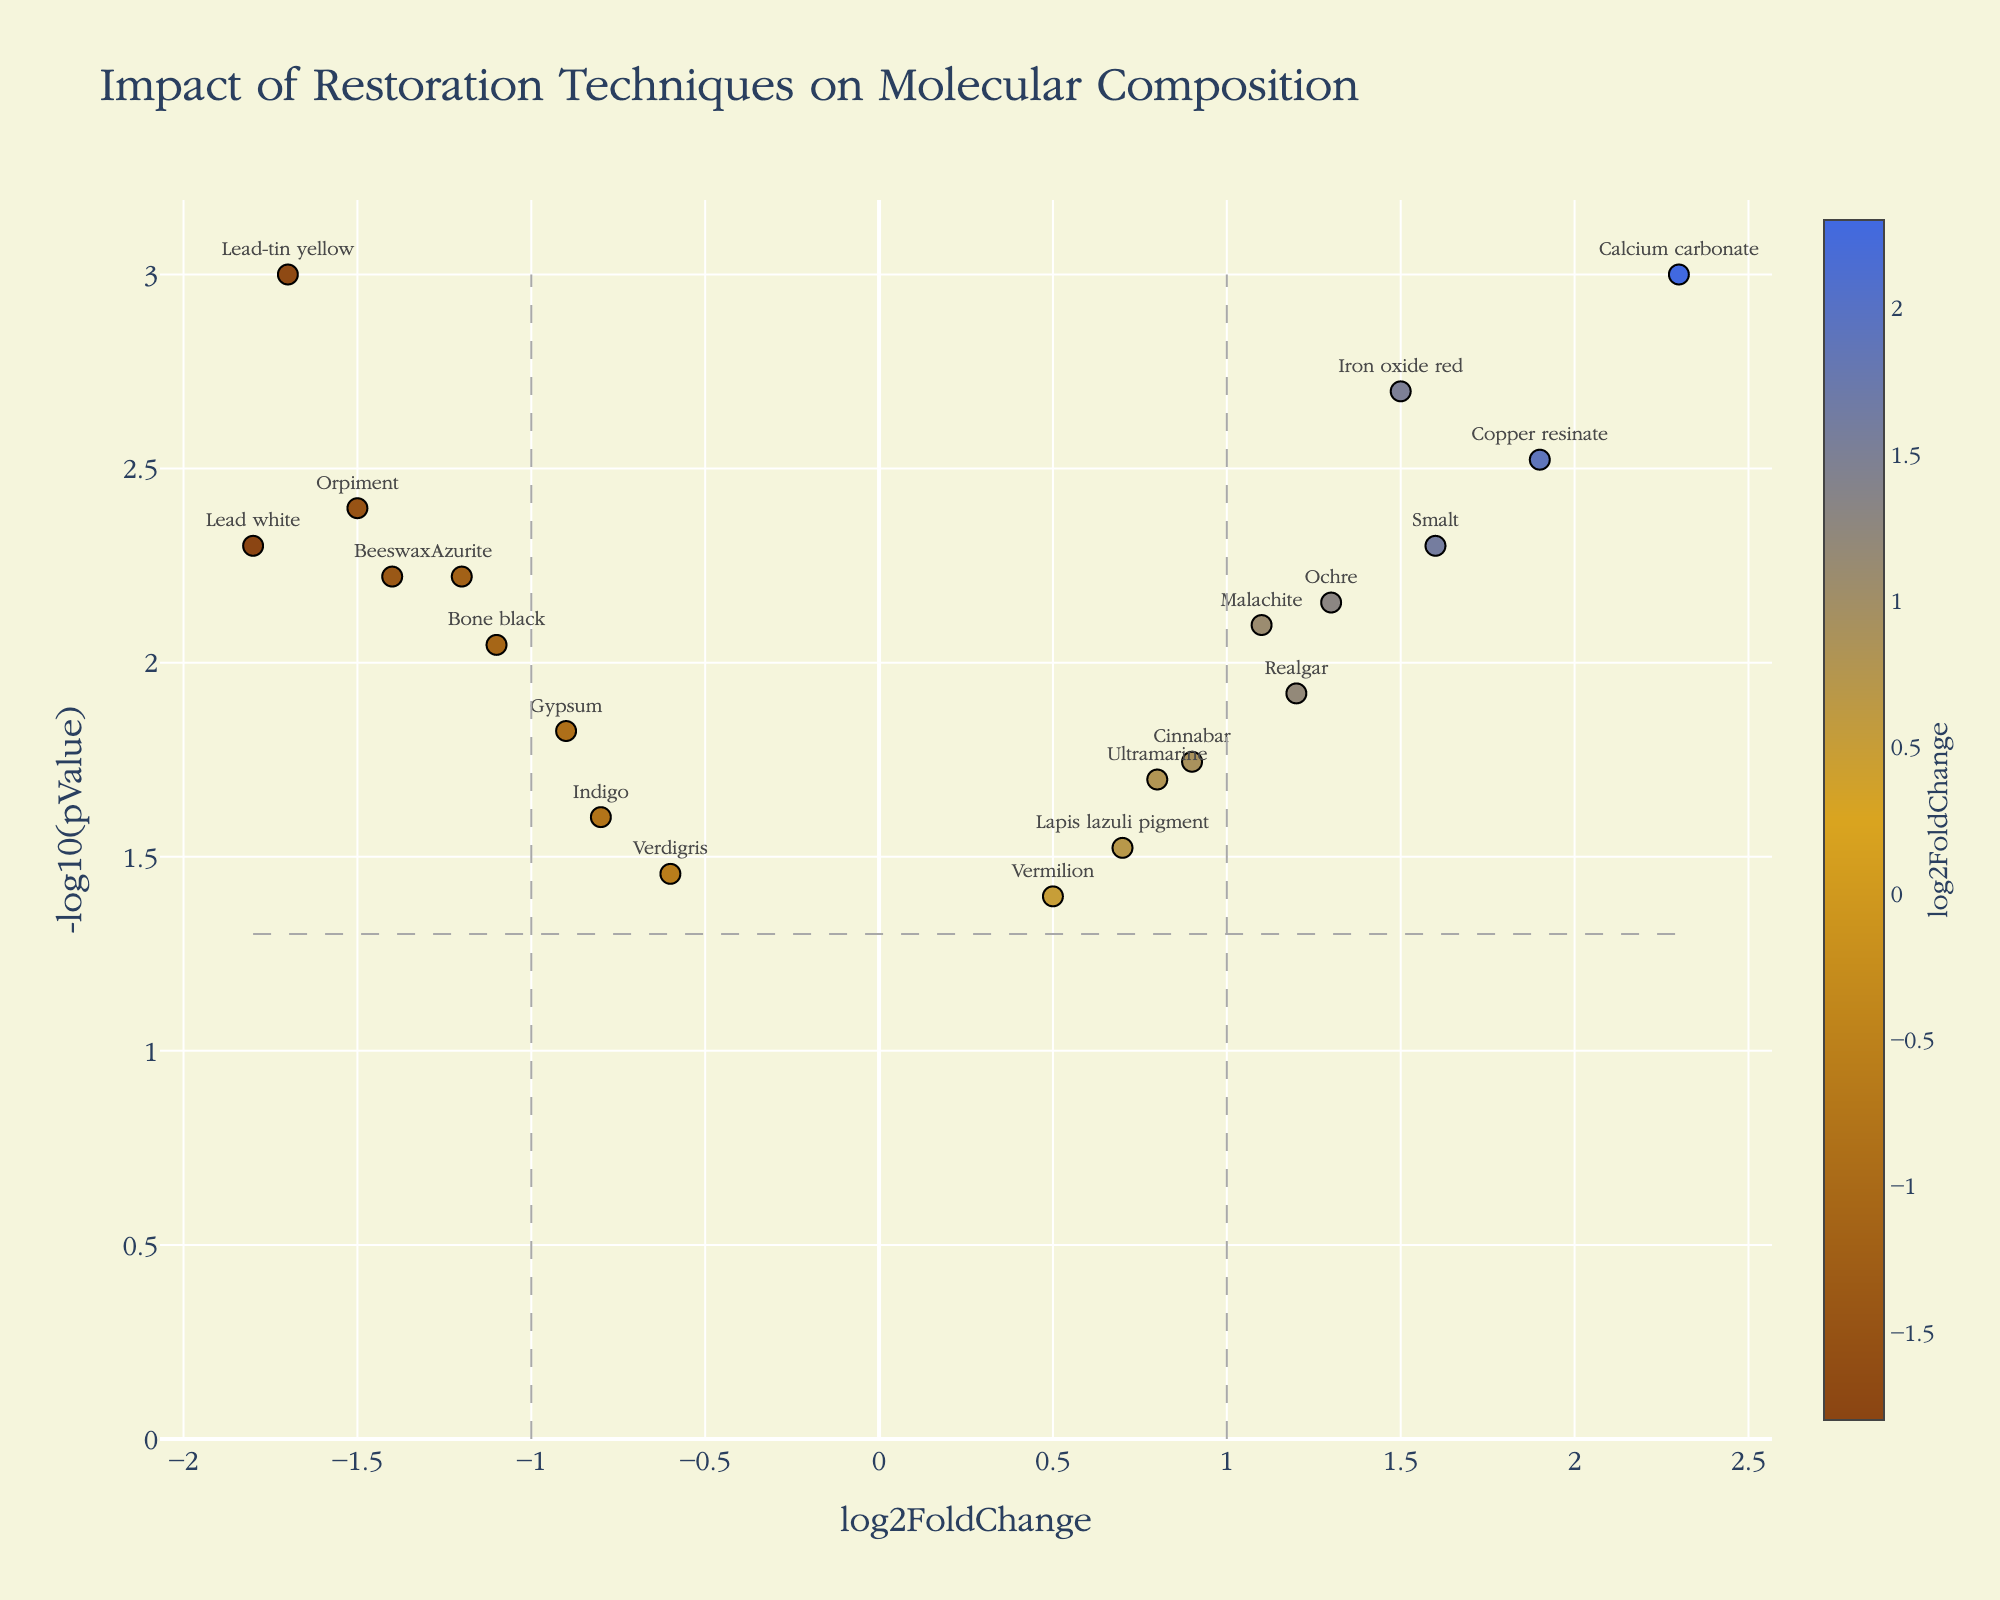How many molecules exhibit a significant p-value (below 0.05)? To determine the number of significant molecules, look for data points that are above the horizontal dashed line at -log10(0.05), corresponding to y > 1.30 on the y-axis. Count these points.
Answer: 19 Which molecule has the highest log2FoldChange? To find the molecule with the highest log2FoldChange, locate the point with the maximum x-value on the x-axis. This is the rightmost point.
Answer: Calcium carbonate Which molecule has the lowest p-value? To identify the molecule with the lowest p-value, find the highest point on the y-axis since -log10(p-value) increases as p-value decreases.
Answer: Calcium carbonate Which molecule has a log2FoldChange closest to zero yet still statistically significant? Isolate points with values close to zero on the x-axis, then check if these points lie above the horizontal threshold for significance (y > 1.30).
Answer: Lapis lazuli pigment Out of Gypsum and Beeswax, which has a higher log2FoldChange? Compare the x-values of Gypsum and Beeswax, observing which value is further to the right (higher).
Answer: Gypsum Which molecules show a negative log2FoldChange and a significant p-value? Identify molecules that lie to the left of x = 0 (negative log2FoldChange) and are above the y-threshold (horizontal line) for significance (y > 1.30).
Answer: Lead white, Azurite, Orpiment, Beeswax, Lead-tin yellow How many molecules are above the p-value significance threshold and also have a log2FoldChange above 1? Count the points in the upper right quadrant, above the horizontal significance threshold and to the right of the vertical threshold at log2FoldChange = 1.
Answer: 7 Which molecule has a log2FoldChange of approximately 1.5 and is also statistically significant? Find the data point near x = 1.5 that lies above the p-value significance threshold (y > 1.30).
Answer: Iron oxide red Compare Iron oxide red and Orpiment in terms of both log2FoldChange and significance. Iron oxide red is located at a positive log2FoldChange (right side) with higher significance (higher y-value), while Orpiment is positioned at a negative log2FoldChange (left side) but also significant.
Answer: Iron oxide red has a higher log2FoldChange and significance Describe the molecular composition changes due to restoration techniques, focusing on elements with significant positive changes. To describe the changes, identify molecules with high positive log2FoldChange values and significant p-values (points in the upper right quadrant). List these molecules.
Answer: Calcium carbonate, Iron oxide red, Copper resinate, Realgar 